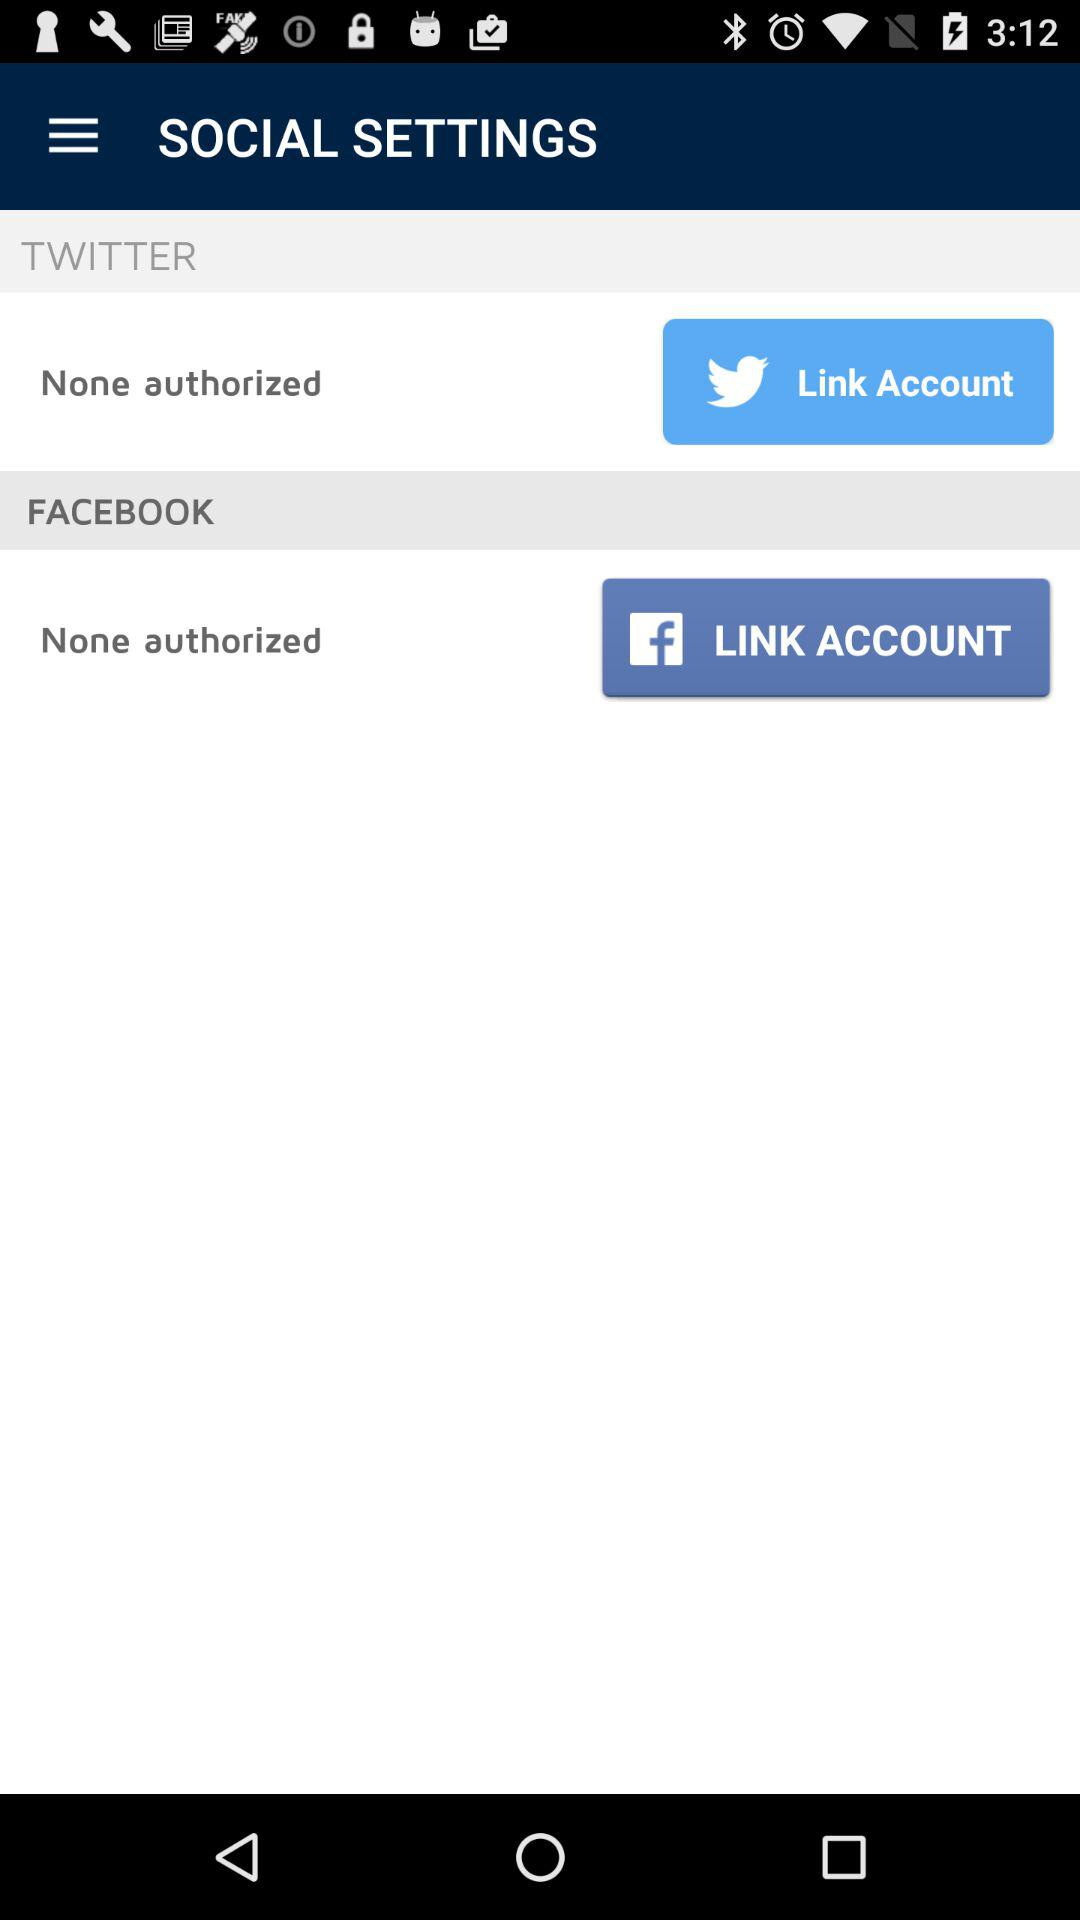How many social accounts are unlinked?
Answer the question using a single word or phrase. 2 